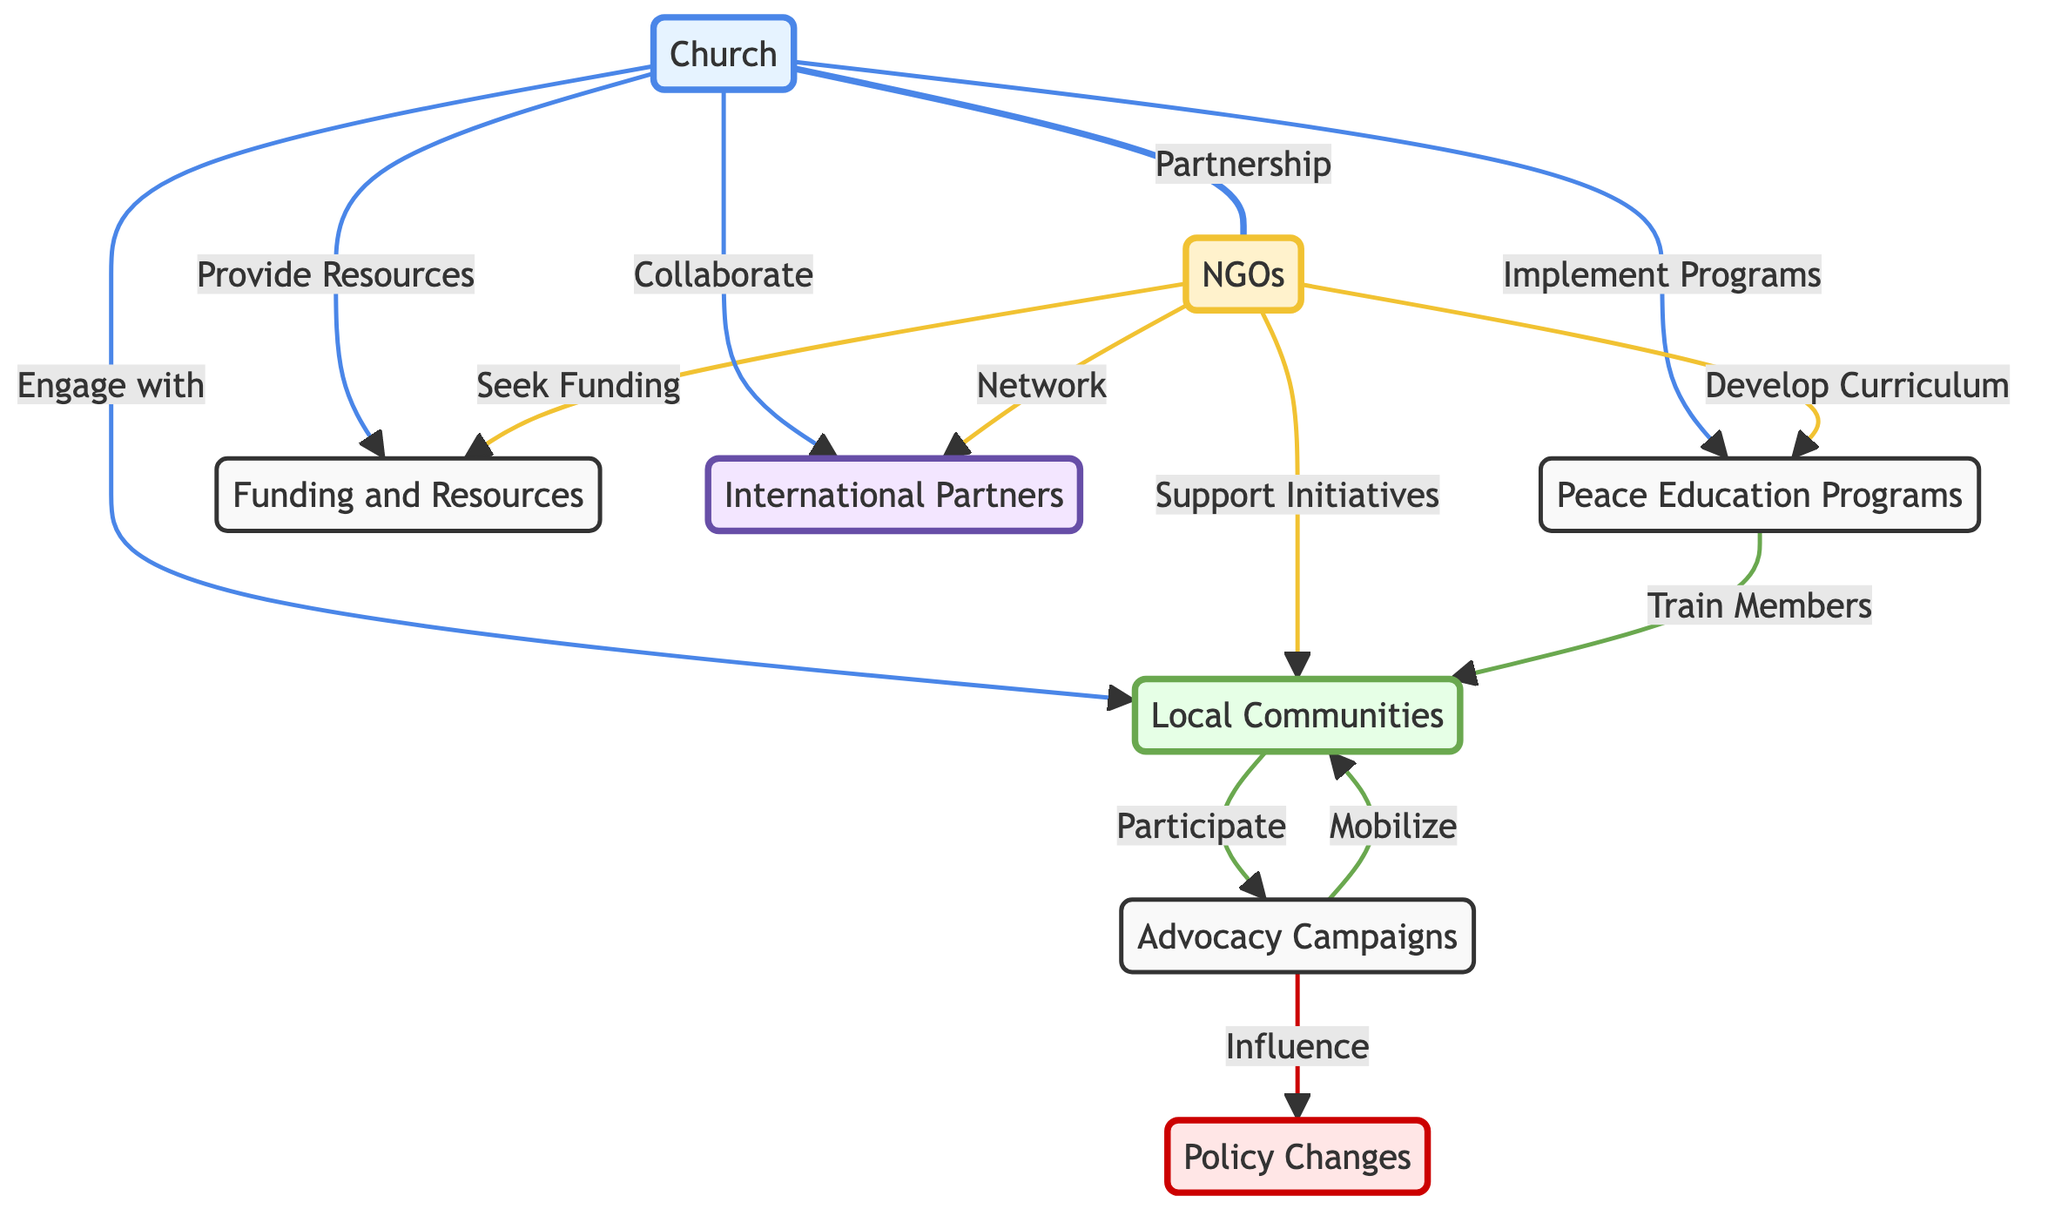What are the two main organizations involved in the collaboration? The diagram indicates two primary organizations: the Church and NGOs, as they are the two main nodes connected by a partnership line.
Answer: Church, NGOs How many main programs are indicated in the flowchart? There are three main programs in the diagram: Peace Education Programs, Advocacy Campaigns, and Policy Changes, which can be counted by identifying the relevant nodes (excluding organizations) in the flowchart.
Answer: 3 Which entity is responsible for developing curriculum in the peace education program? According to the diagram, the NGOs are indicated as the entity responsible for developing the curriculum for Peace Education Programs.
Answer: NGOs What do local communities do in relation to advocacy? The diagram shows that local communities participate in advocacy, indicating their active role in that specific initiative.
Answer: Participate How do the Church and NGOs collaborate with international partners? The diagram specifies that both the Church and NGOs collaborate or network with International Partners, implying their interconnected roles in global advocacy.
Answer: Collaborate, Network What is the flow of influence from advocacy to policy? The flow from the Advocacy Campaigns shows a direct influence to Policy Changes, indicating that efforts made in advocacy can directly impact policy decisions.
Answer: Influence Which two entities engage with local communities? The diagram indicates that both the Church and NGOs engage with local communities, demonstrating their direct interaction and involvement in community initiatives.
Answer: Church, NGOs What is a direct outcome of the Peace Education Programs? The diagram specifies that the outcome of Peace Education Programs is training members of local communities, demonstrating the targeted impact of the educational initiatives.
Answer: Train Members How does funding relate to the Church and NGOs? The flowchart shows that both the Church provides resources and NGOs seek funding, indicating a dual relationship regarding funding and resources in their collaborative efforts.
Answer: Provide, Seek What are the different roles of NGOs regarding local communities? In the diagram, NGOs support initiatives and develop curricula that engage local communities, reflecting their multifaceted role in community involvement.
Answer: Support Initiatives, Develop Curriculum 